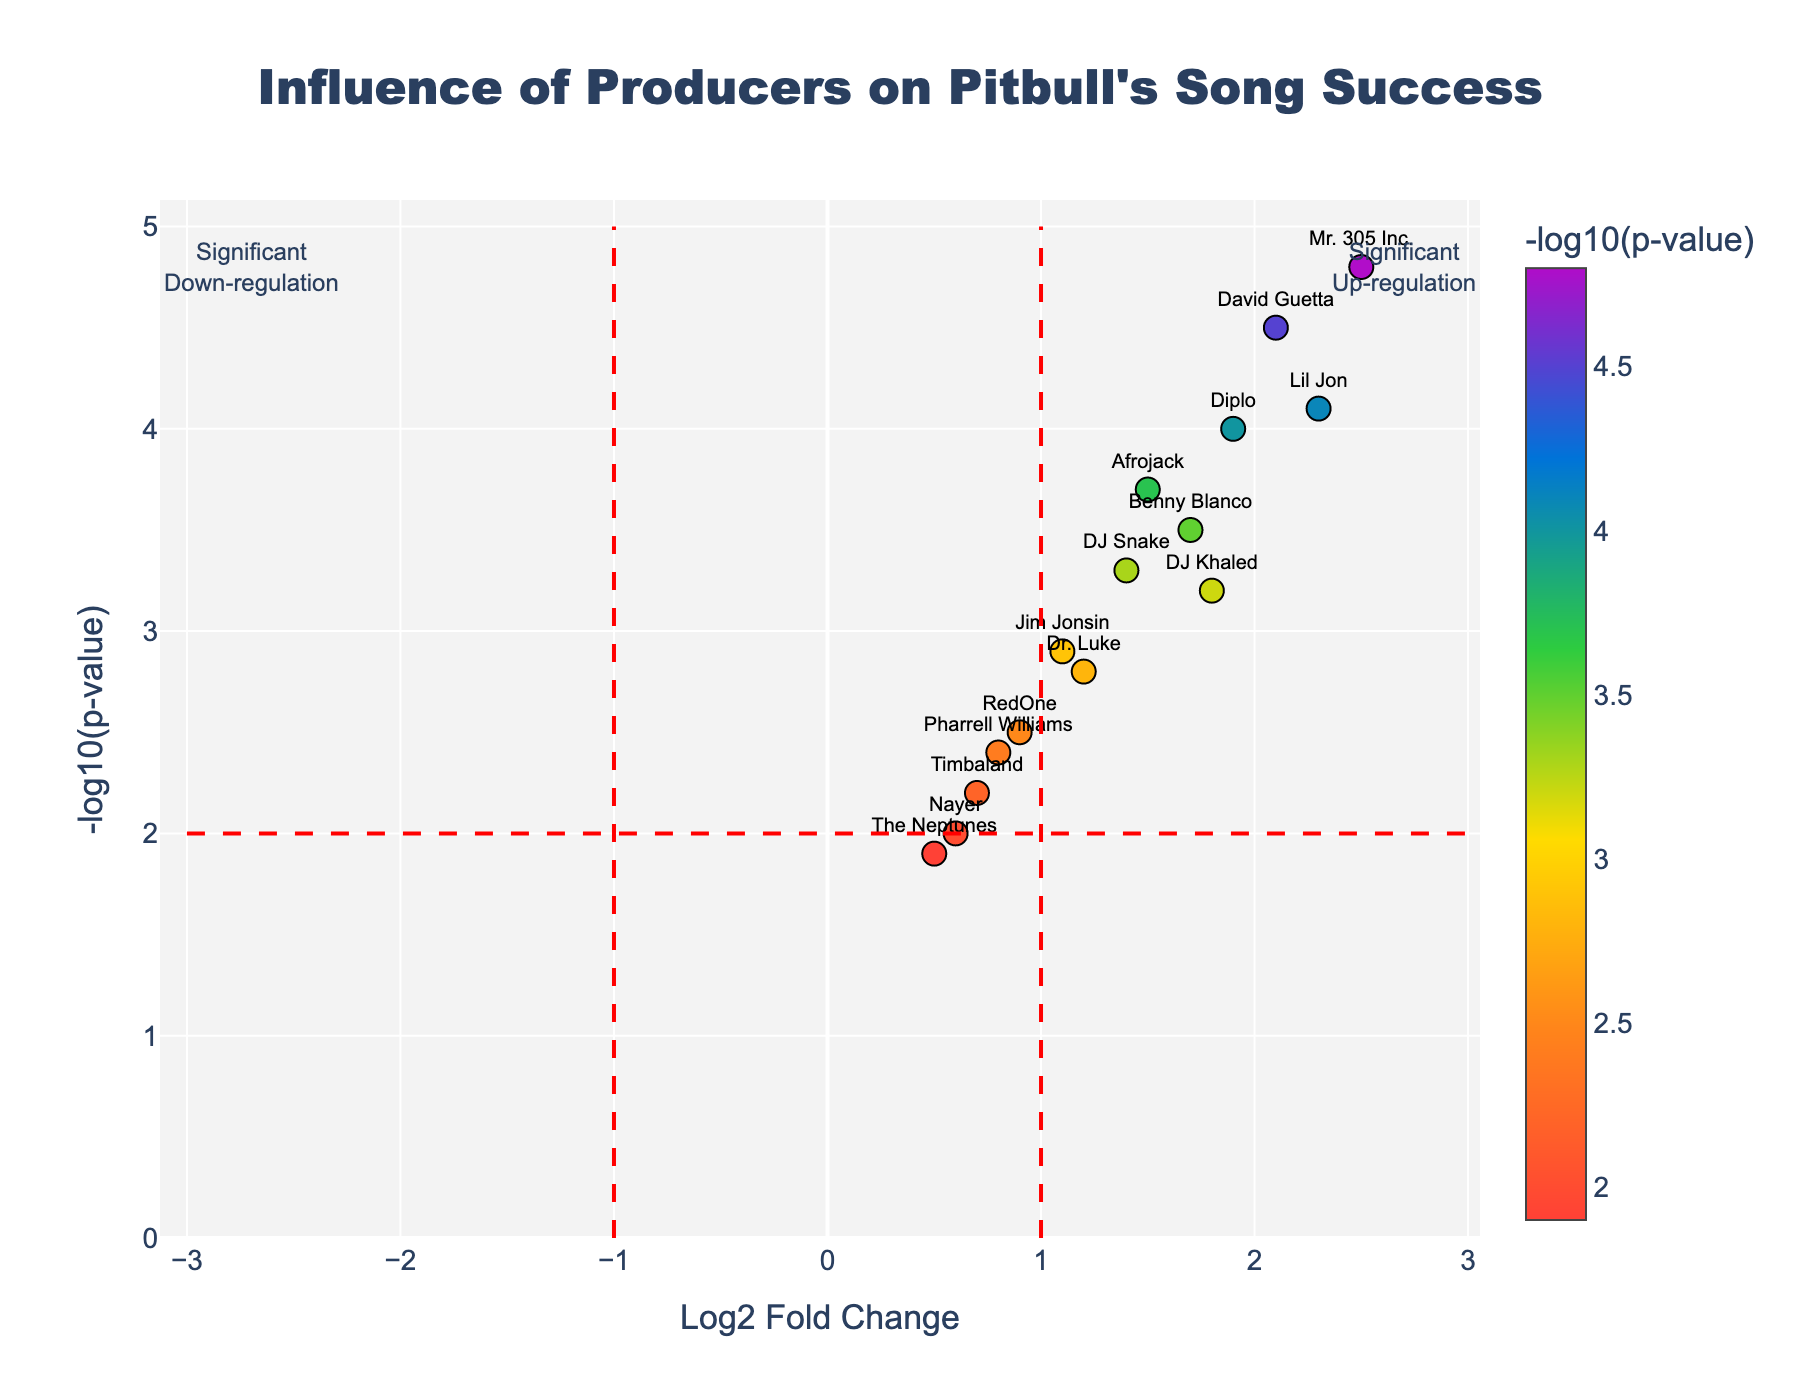What is the title of the plot? The title of the plot is found at the top center of the figure and it states what the plot is about.
Answer: Influence of Producers on Pitbull's Song Success Which producer has the highest negative log10 p-value? By looking at the y-axis, the data point that reaches the highest value represents the highest negative log10 p-value.
Answer: Mr. 305 Inc How many producers show a log2 fold change greater than 1? By examining the x-axis and counting the data points to the right of the vertical line at Log2 Fold Change = 1, we can determine the number of producers meeting this criteria.
Answer: 8 Which producer has both a high log2 fold change and a high negative log10 p-value? By looking at the top-right section of the plot where both the x-axis and y-axis have large values, identify the producer in this region.
Answer: Mr. 305 Inc Who has a higher log2 fold change: DJ Khaled or David Guetta? Compare the x-axis values (log2 fold change) for DJ Khaled and David Guetta to see which is higher.
Answer: David Guetta What does the horizontal red dashed line represent? The horizontal red dashed line indicates a threshold for statistical significance on the y-axis (-log10 p-value).
Answer: p-value threshold for significance How many producers have a negative log10 p-value above 3.0? By looking at the y-axis and counting all points that lie above the y=3.0 line, we can determine the number of producers.
Answer: 7 Which producer has the smallest log2 fold change? By examining the x-axis, find the data point closest to the origin or the farthest left to identify the producer with the smallest log2 fold change.
Answer: The Neptunes What is the log2 fold change and negative log10 p-value for Lil Jon? Identify Lil Jon's data point and read off the values from the x-axis and y-axis.
Answer: 2.3, 4.1 Which producers are annotated with "Significant Up-regulation"? Producers that lie in the region marked with an annotation for significant up-regulation (usually high log2 fold change and high negative log10 p-value) are the ones of interest.
Answer: Producers to the right of the vertical line at Log2 Fold Change = 1 and above the horizontal line at -log10(p-value) = 2 